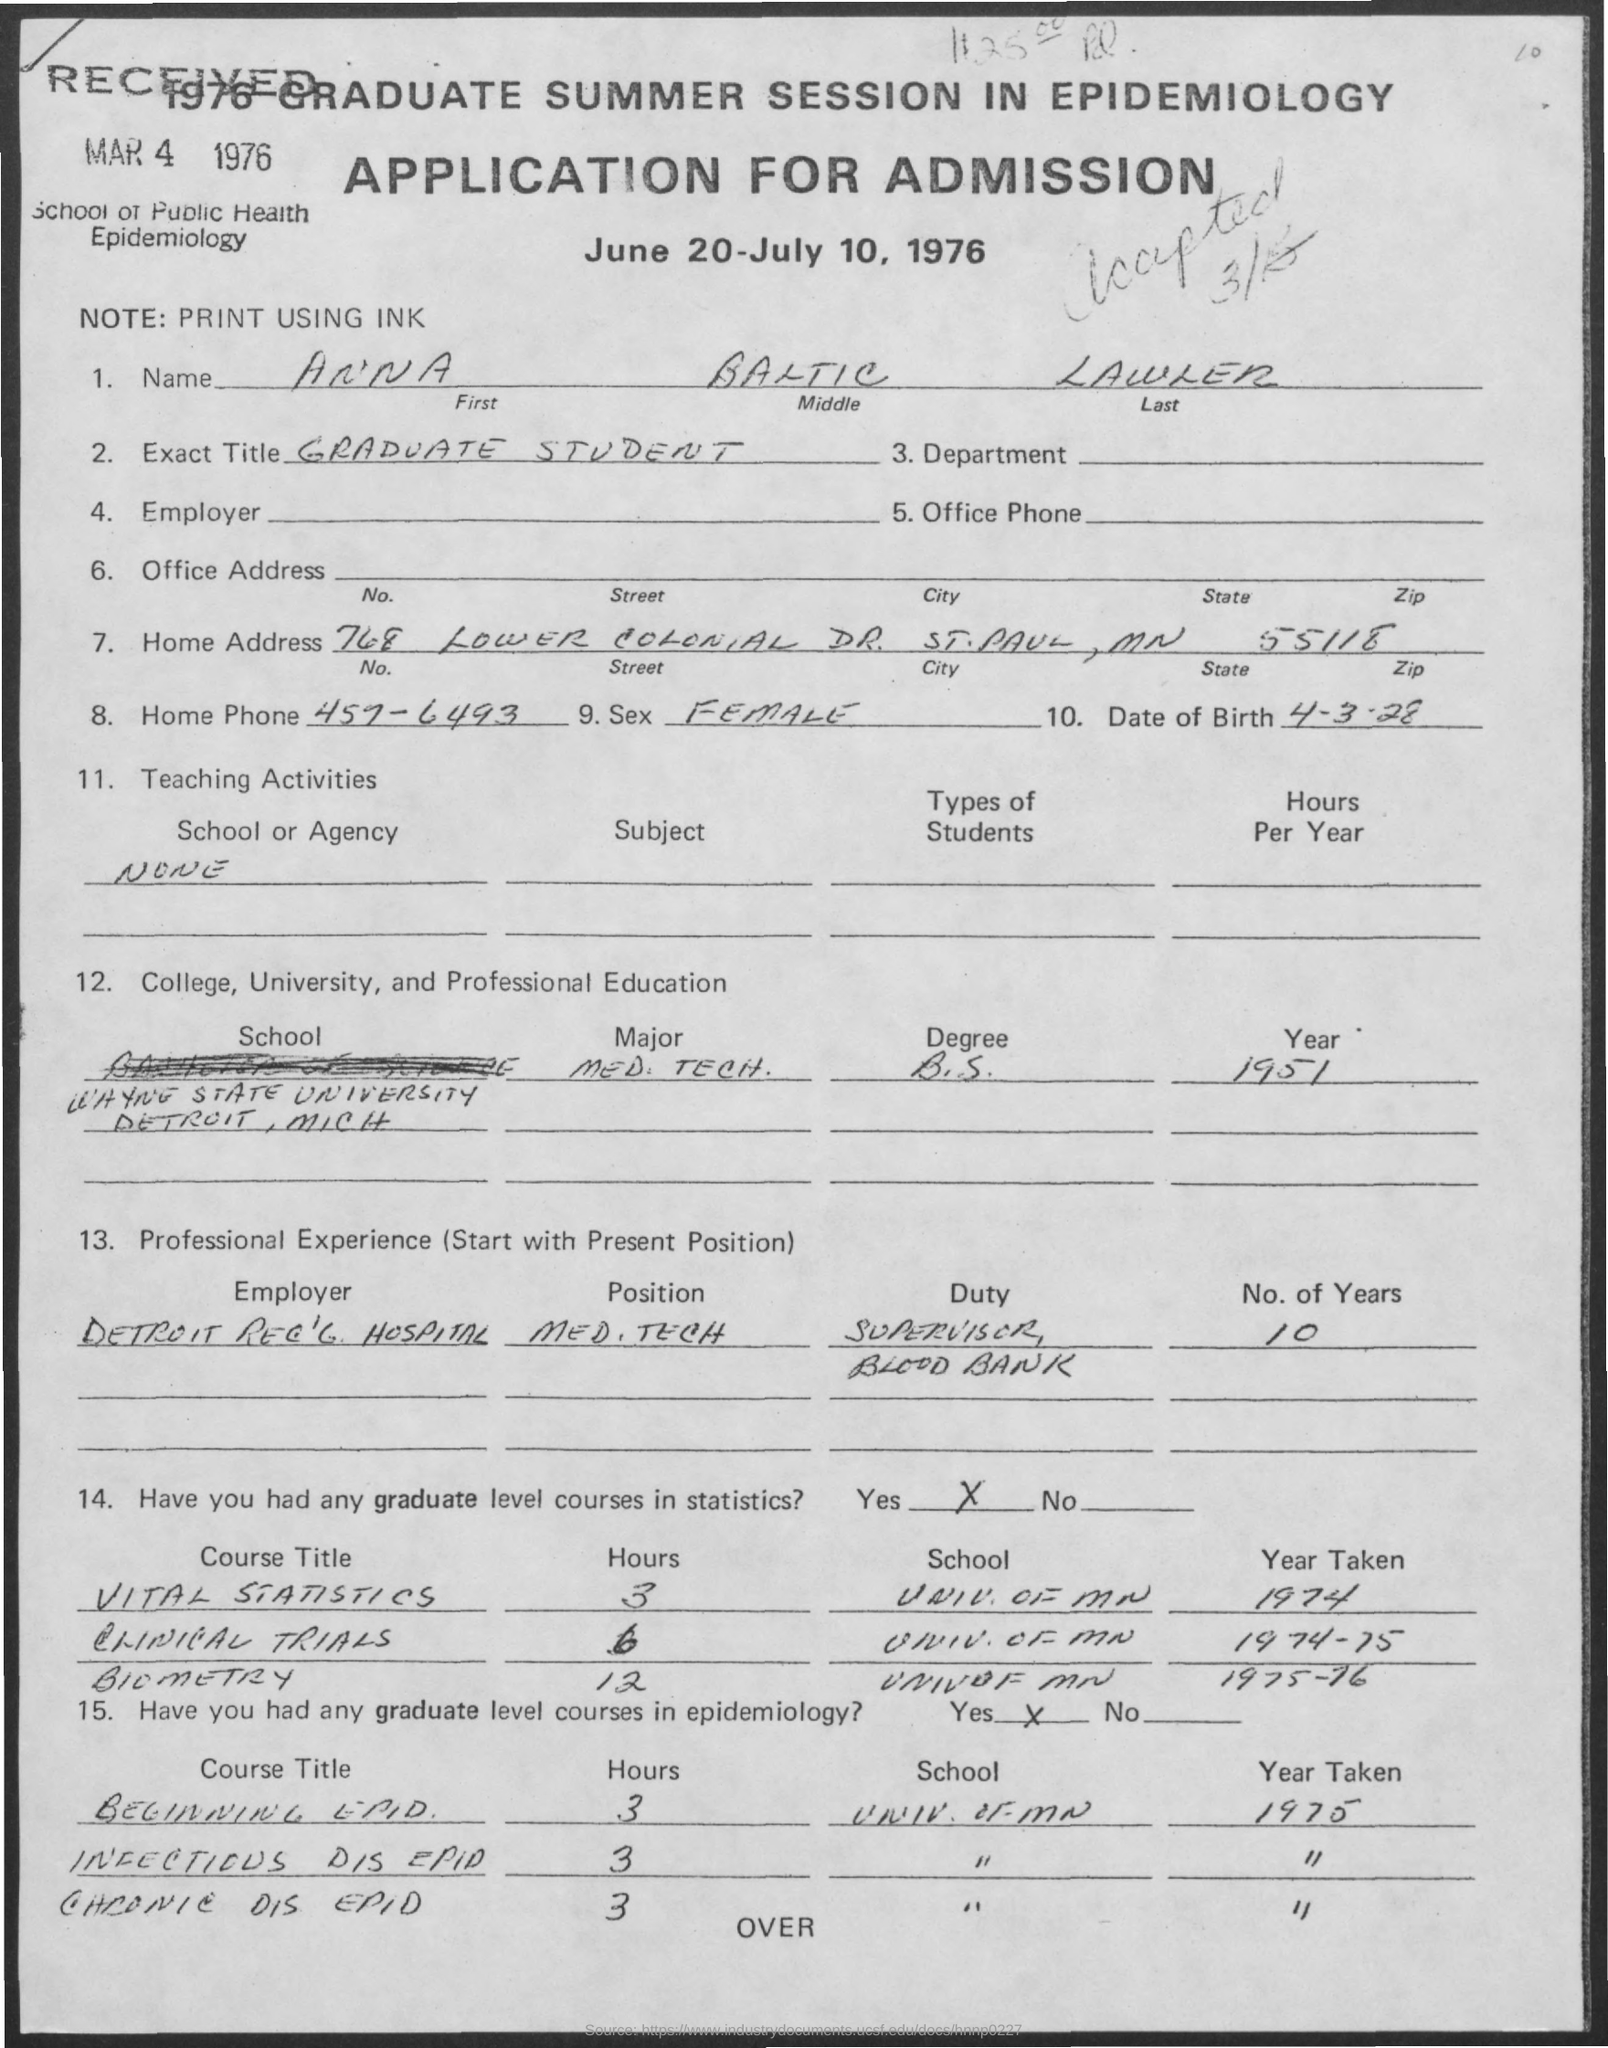Draw attention to some important aspects in this diagram. The individual has accumulated 10 years of professional experience. The date for the application for admission was June 20-July 10, 1976. The home phone number is 457-6493. The zip code mentioned in the address is 55118. In 1951, James completed his degree. 